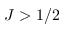<formula> <loc_0><loc_0><loc_500><loc_500>J > 1 / 2</formula> 